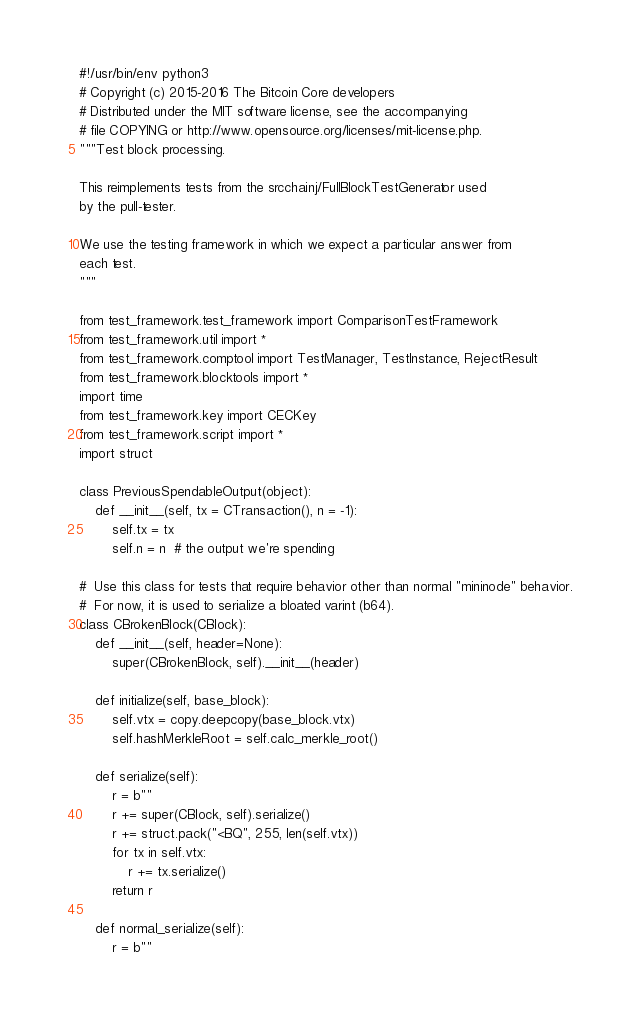Convert code to text. <code><loc_0><loc_0><loc_500><loc_500><_Python_>#!/usr/bin/env python3
# Copyright (c) 2015-2016 The Bitcoin Core developers
# Distributed under the MIT software license, see the accompanying
# file COPYING or http://www.opensource.org/licenses/mit-license.php.
"""Test block processing.

This reimplements tests from the srcchainj/FullBlockTestGenerator used
by the pull-tester.

We use the testing framework in which we expect a particular answer from
each test.
"""

from test_framework.test_framework import ComparisonTestFramework
from test_framework.util import *
from test_framework.comptool import TestManager, TestInstance, RejectResult
from test_framework.blocktools import *
import time
from test_framework.key import CECKey
from test_framework.script import *
import struct

class PreviousSpendableOutput(object):
    def __init__(self, tx = CTransaction(), n = -1):
        self.tx = tx
        self.n = n  # the output we're spending

#  Use this class for tests that require behavior other than normal "mininode" behavior.
#  For now, it is used to serialize a bloated varint (b64).
class CBrokenBlock(CBlock):
    def __init__(self, header=None):
        super(CBrokenBlock, self).__init__(header)

    def initialize(self, base_block):
        self.vtx = copy.deepcopy(base_block.vtx)
        self.hashMerkleRoot = self.calc_merkle_root()

    def serialize(self):
        r = b""
        r += super(CBlock, self).serialize()
        r += struct.pack("<BQ", 255, len(self.vtx))
        for tx in self.vtx:
            r += tx.serialize()
        return r

    def normal_serialize(self):
        r = b""</code> 